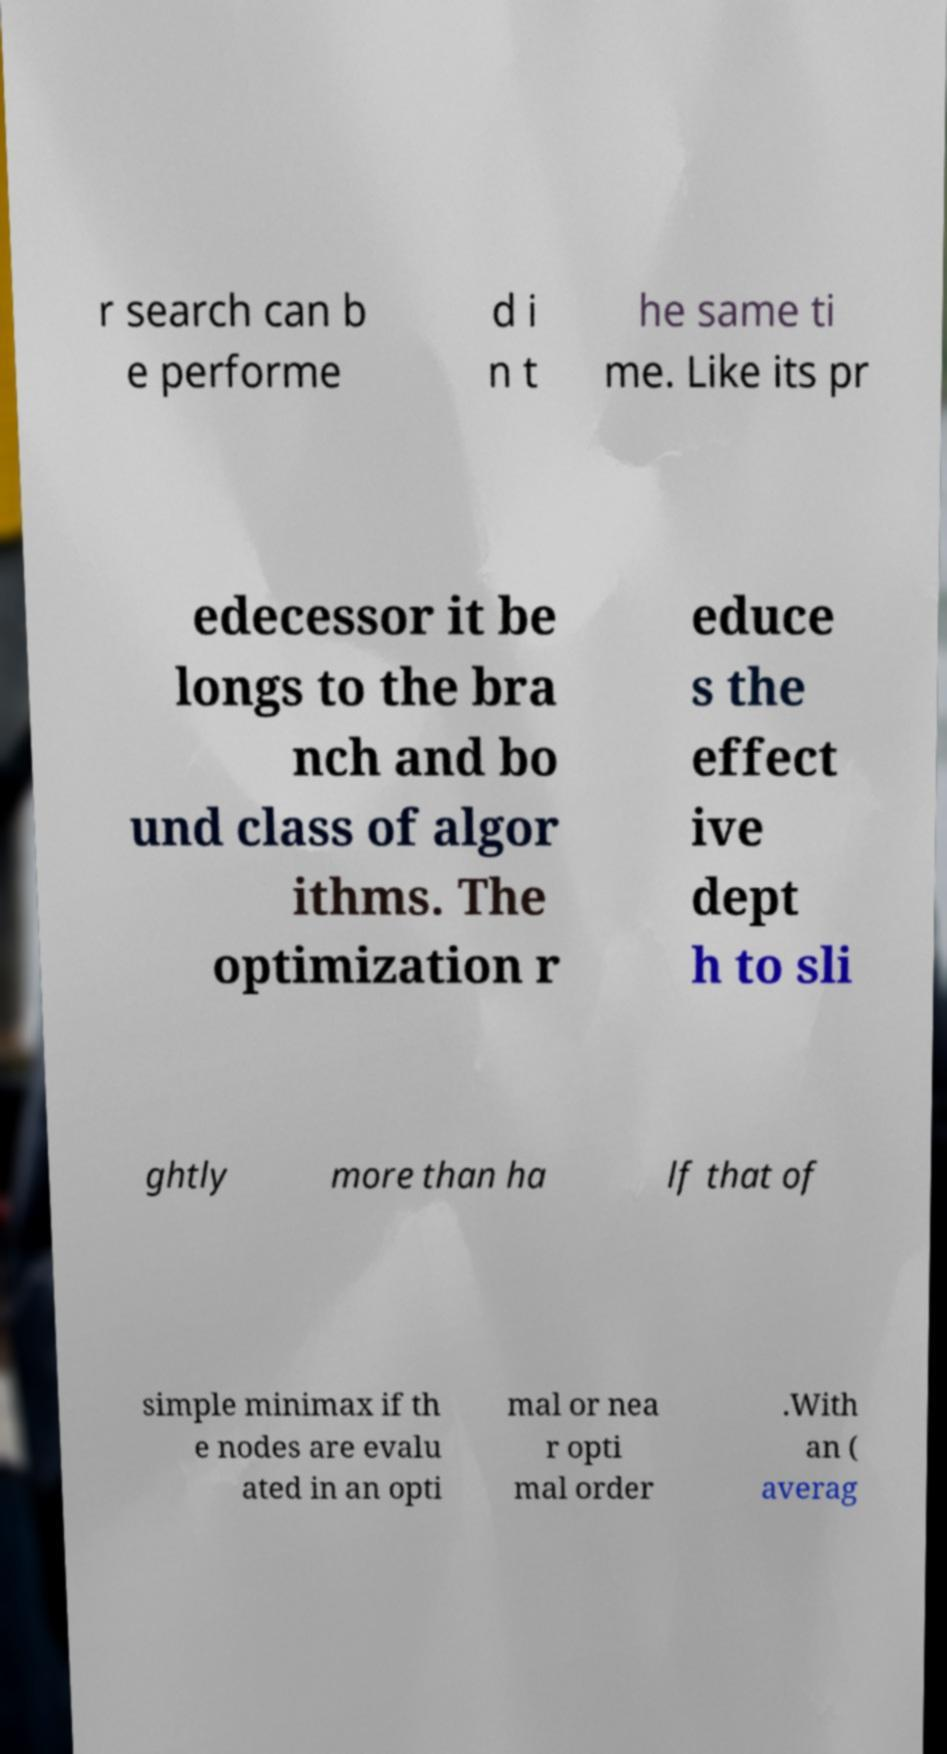Could you extract and type out the text from this image? r search can b e performe d i n t he same ti me. Like its pr edecessor it be longs to the bra nch and bo und class of algor ithms. The optimization r educe s the effect ive dept h to sli ghtly more than ha lf that of simple minimax if th e nodes are evalu ated in an opti mal or nea r opti mal order .With an ( averag 